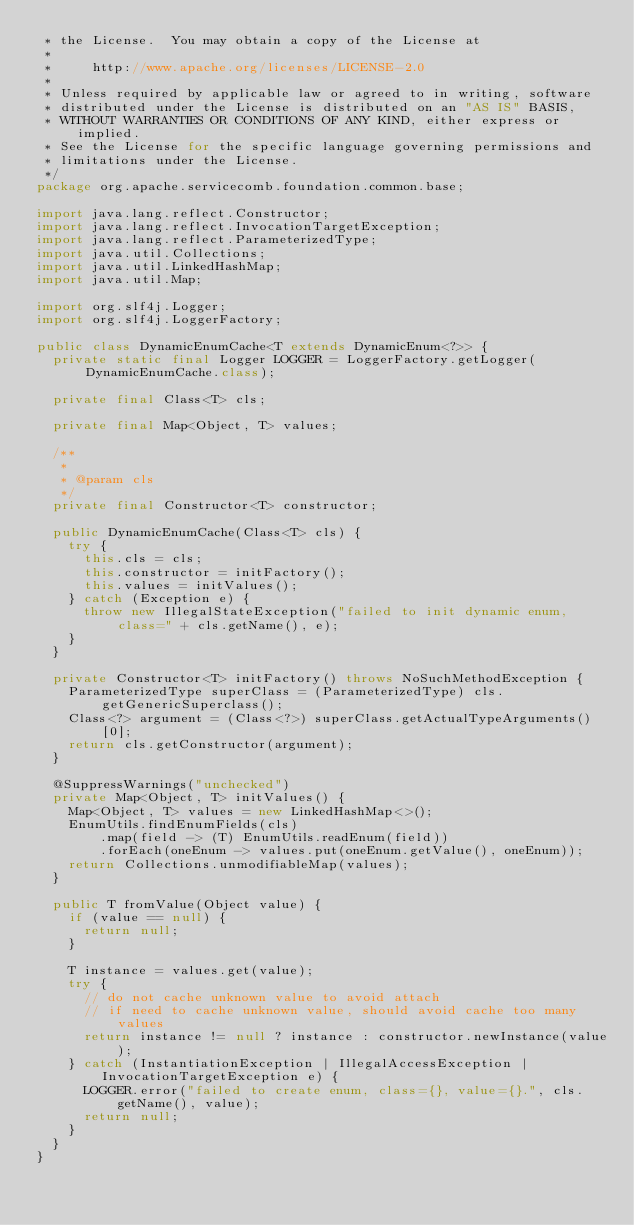<code> <loc_0><loc_0><loc_500><loc_500><_Java_> * the License.  You may obtain a copy of the License at
 *
 *     http://www.apache.org/licenses/LICENSE-2.0
 *
 * Unless required by applicable law or agreed to in writing, software
 * distributed under the License is distributed on an "AS IS" BASIS,
 * WITHOUT WARRANTIES OR CONDITIONS OF ANY KIND, either express or implied.
 * See the License for the specific language governing permissions and
 * limitations under the License.
 */
package org.apache.servicecomb.foundation.common.base;

import java.lang.reflect.Constructor;
import java.lang.reflect.InvocationTargetException;
import java.lang.reflect.ParameterizedType;
import java.util.Collections;
import java.util.LinkedHashMap;
import java.util.Map;

import org.slf4j.Logger;
import org.slf4j.LoggerFactory;

public class DynamicEnumCache<T extends DynamicEnum<?>> {
  private static final Logger LOGGER = LoggerFactory.getLogger(DynamicEnumCache.class);

  private final Class<T> cls;

  private final Map<Object, T> values;

  /**
   *
   * @param cls
   */
  private final Constructor<T> constructor;

  public DynamicEnumCache(Class<T> cls) {
    try {
      this.cls = cls;
      this.constructor = initFactory();
      this.values = initValues();
    } catch (Exception e) {
      throw new IllegalStateException("failed to init dynamic enum, class=" + cls.getName(), e);
    }
  }

  private Constructor<T> initFactory() throws NoSuchMethodException {
    ParameterizedType superClass = (ParameterizedType) cls.getGenericSuperclass();
    Class<?> argument = (Class<?>) superClass.getActualTypeArguments()[0];
    return cls.getConstructor(argument);
  }

  @SuppressWarnings("unchecked")
  private Map<Object, T> initValues() {
    Map<Object, T> values = new LinkedHashMap<>();
    EnumUtils.findEnumFields(cls)
        .map(field -> (T) EnumUtils.readEnum(field))
        .forEach(oneEnum -> values.put(oneEnum.getValue(), oneEnum));
    return Collections.unmodifiableMap(values);
  }

  public T fromValue(Object value) {
    if (value == null) {
      return null;
    }

    T instance = values.get(value);
    try {
      // do not cache unknown value to avoid attach
      // if need to cache unknown value, should avoid cache too many values
      return instance != null ? instance : constructor.newInstance(value);
    } catch (InstantiationException | IllegalAccessException | InvocationTargetException e) {
      LOGGER.error("failed to create enum, class={}, value={}.", cls.getName(), value);
      return null;
    }
  }
}
</code> 